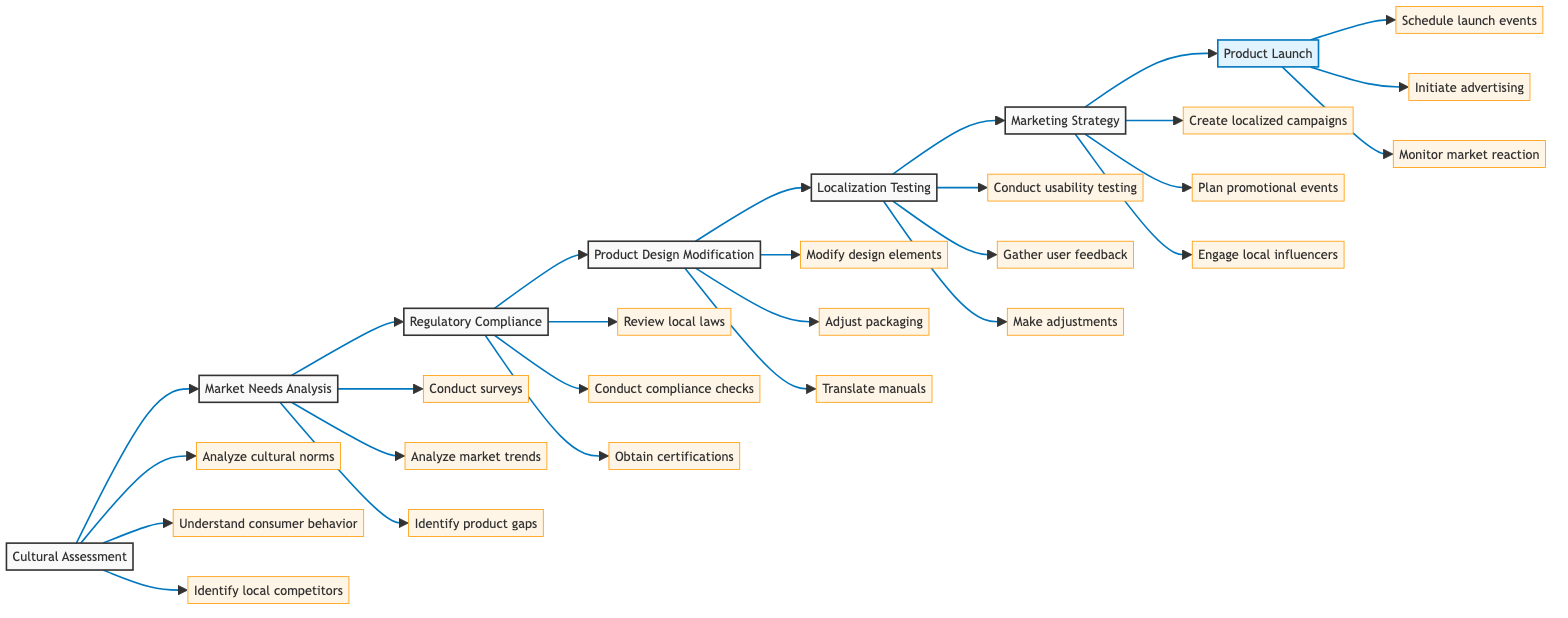What is the first step in the product adaptation process? The diagram clearly identifies the first step as 'Cultural Assessment'. This is explicitly stated as the first node in the horizontal flowchart.
Answer: Cultural Assessment How many key actions are listed under 'Localization Testing'? By examining the 'Localization Testing' node in the flowchart, there are three actions: 'Conduct usability testing', 'Gather user feedback', and 'Make adjustments'.
Answer: 3 Which team is responsible for 'Product Design Modification'? The diagram labels the 'Design and Engineering Team' as responsible for the step 'Product Design Modification'. This information can be found in the description associated with that node.
Answer: Design and Engineering Team What follows after 'Regulatory Compliance' in the flowchart? Following the 'Regulatory Compliance' node, the flowchart directs to 'Product Design Modification'. This shows the sequence of steps in the process.
Answer: Product Design Modification List the actions involved in 'Market Needs Analysis'. The key actions listed under 'Market Needs Analysis' are: 'Conduct surveys and focus groups', 'Analyze local market trends', and 'Identify product gaps'. These are directly mentioned under that node.
Answer: Conduct surveys and focus groups, Analyze local market trends, Identify product gaps How does 'Cultural Assessment' relate to 'Market Needs Analysis'? 'Cultural Assessment' is the prerequisite step that leads to 'Market Needs Analysis', illustrating the linear progression of actions in the flowchart.
Answer: Cultural Assessment leads to Market Needs Analysis What is the last step before the product gets launched? The final step preceding the product launch is 'Marketing Strategy', which is highlighted as the second to last node in the diagram.
Answer: Marketing Strategy Which real-world entity is associated with 'Regulatory Compliance'? The flowchart connects 'Regulatory Compliance' to 'Legal Advisory by Deloitte' as the relevant real-world entity, indicated in the description of that step.
Answer: Legal Advisory by Deloitte 